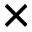Convert formula to latex. <formula><loc_0><loc_0><loc_500><loc_500>\times</formula> 